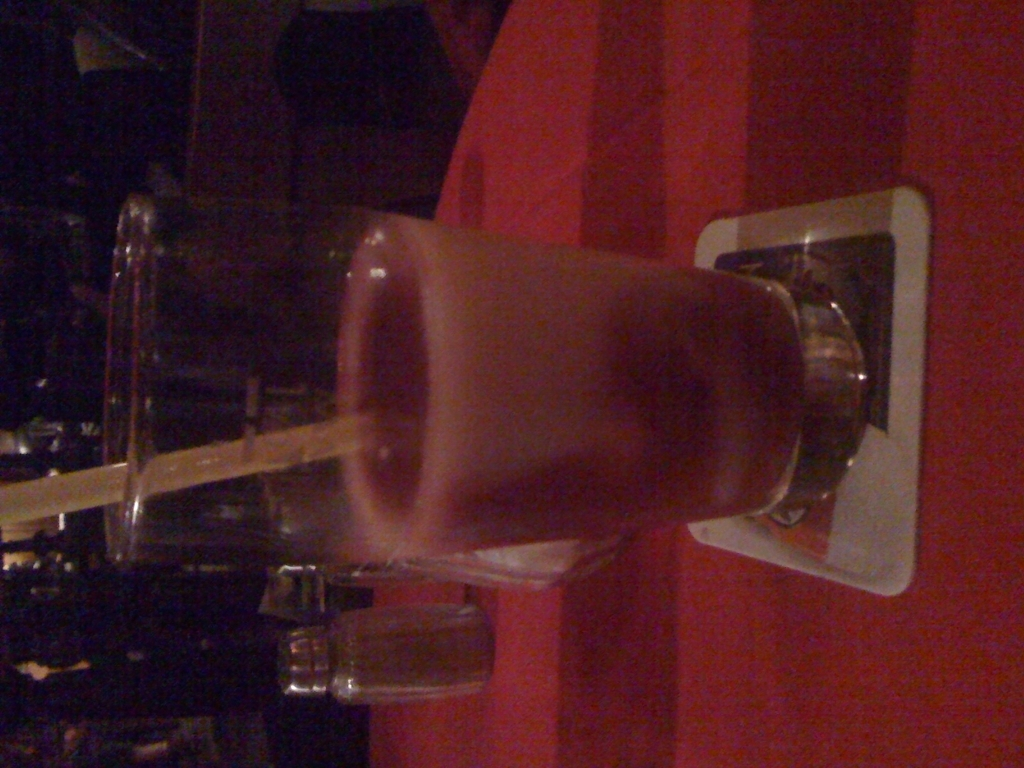Could this image be part of a restaurant or bar advertisement? Although the current quality and presentation of the image are not ideal for commercial use, with enhancements such as correcting the orientation, improving the lighting, and ensuring a sharper focus, it could potentially be used in an advertisement for a restaurant or bar to showcase their beverage offerings. 